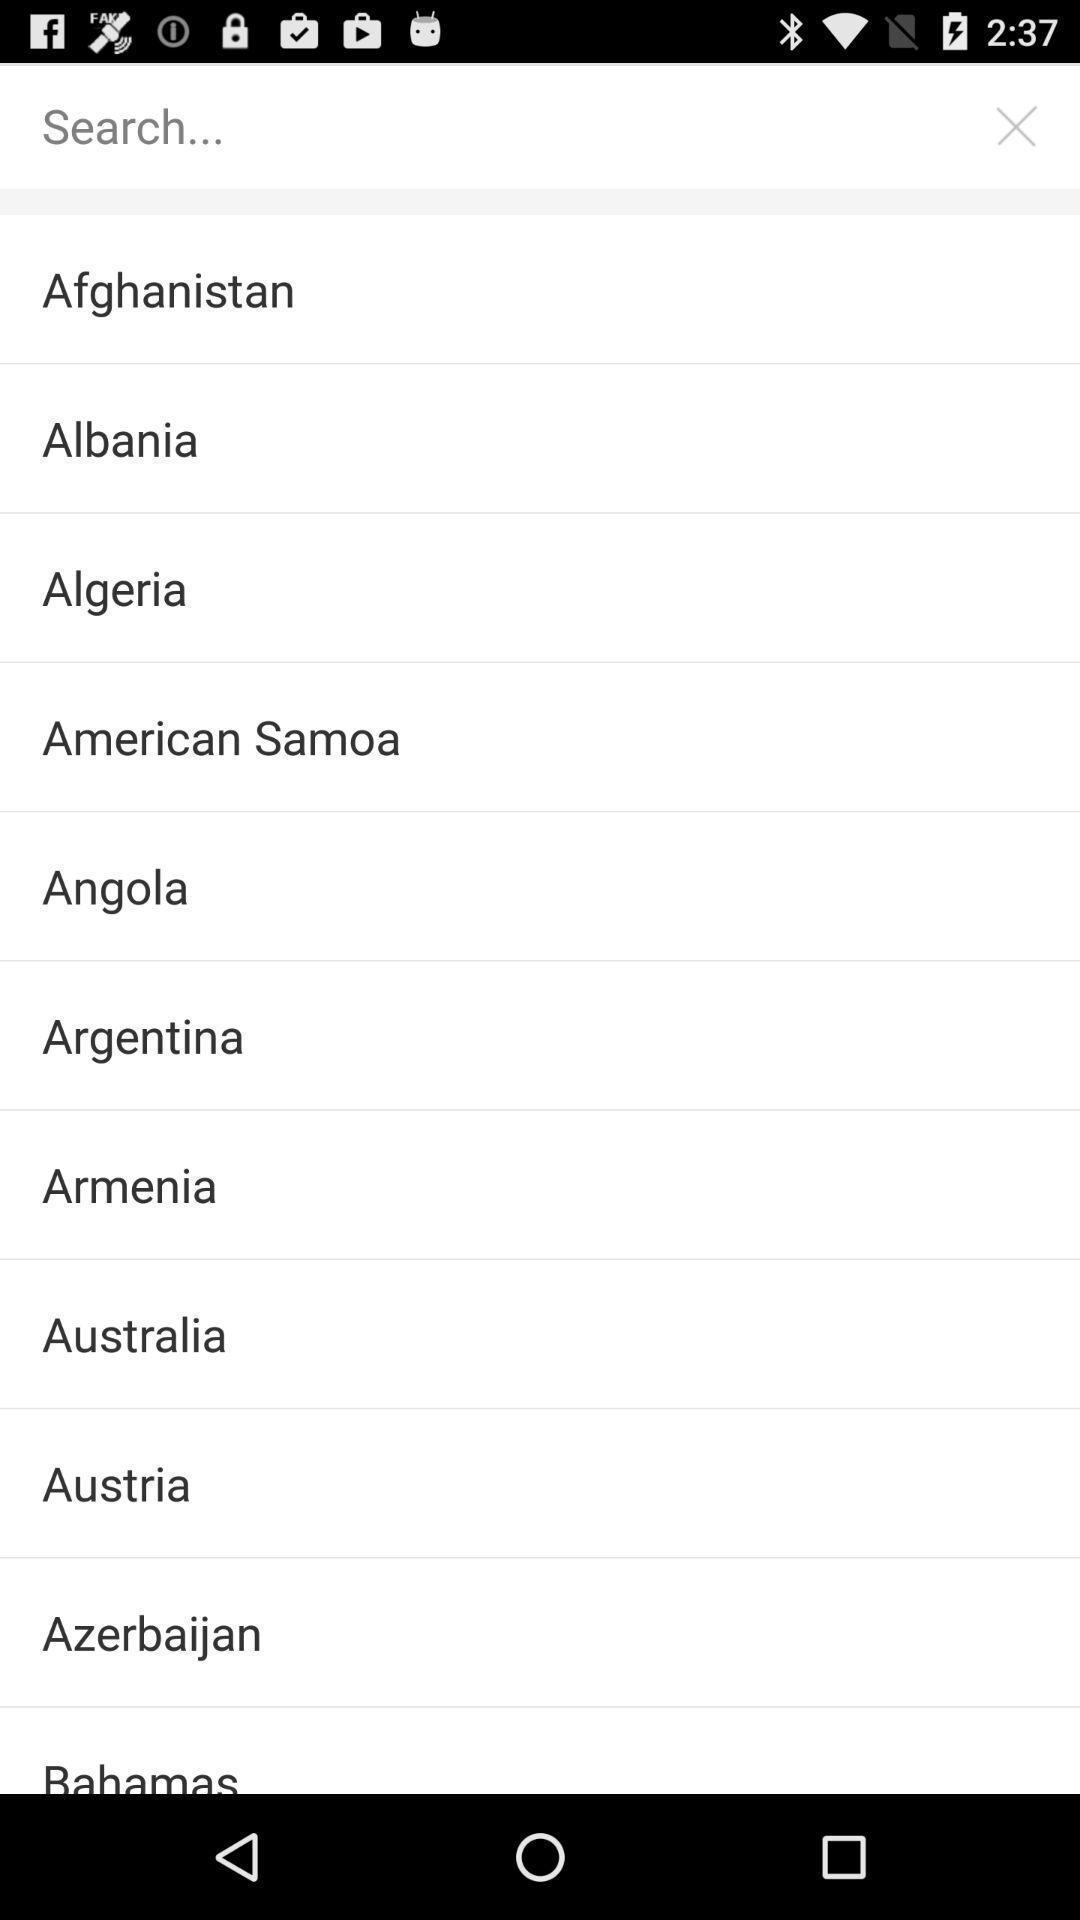Please provide a description for this image. Search bar to search for the country. 